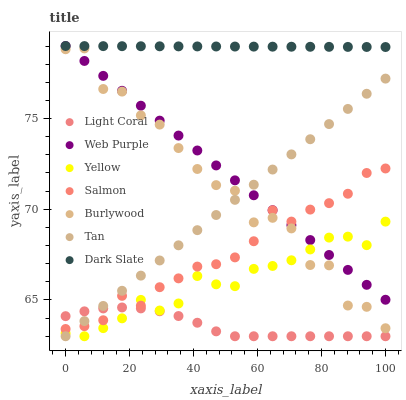Does Light Coral have the minimum area under the curve?
Answer yes or no. Yes. Does Dark Slate have the maximum area under the curve?
Answer yes or no. Yes. Does Salmon have the minimum area under the curve?
Answer yes or no. No. Does Salmon have the maximum area under the curve?
Answer yes or no. No. Is Tan the smoothest?
Answer yes or no. Yes. Is Burlywood the roughest?
Answer yes or no. Yes. Is Salmon the smoothest?
Answer yes or no. No. Is Salmon the roughest?
Answer yes or no. No. Does Yellow have the lowest value?
Answer yes or no. Yes. Does Salmon have the lowest value?
Answer yes or no. No. Does Web Purple have the highest value?
Answer yes or no. Yes. Does Salmon have the highest value?
Answer yes or no. No. Is Salmon less than Dark Slate?
Answer yes or no. Yes. Is Burlywood greater than Light Coral?
Answer yes or no. Yes. Does Burlywood intersect Tan?
Answer yes or no. Yes. Is Burlywood less than Tan?
Answer yes or no. No. Is Burlywood greater than Tan?
Answer yes or no. No. Does Salmon intersect Dark Slate?
Answer yes or no. No. 